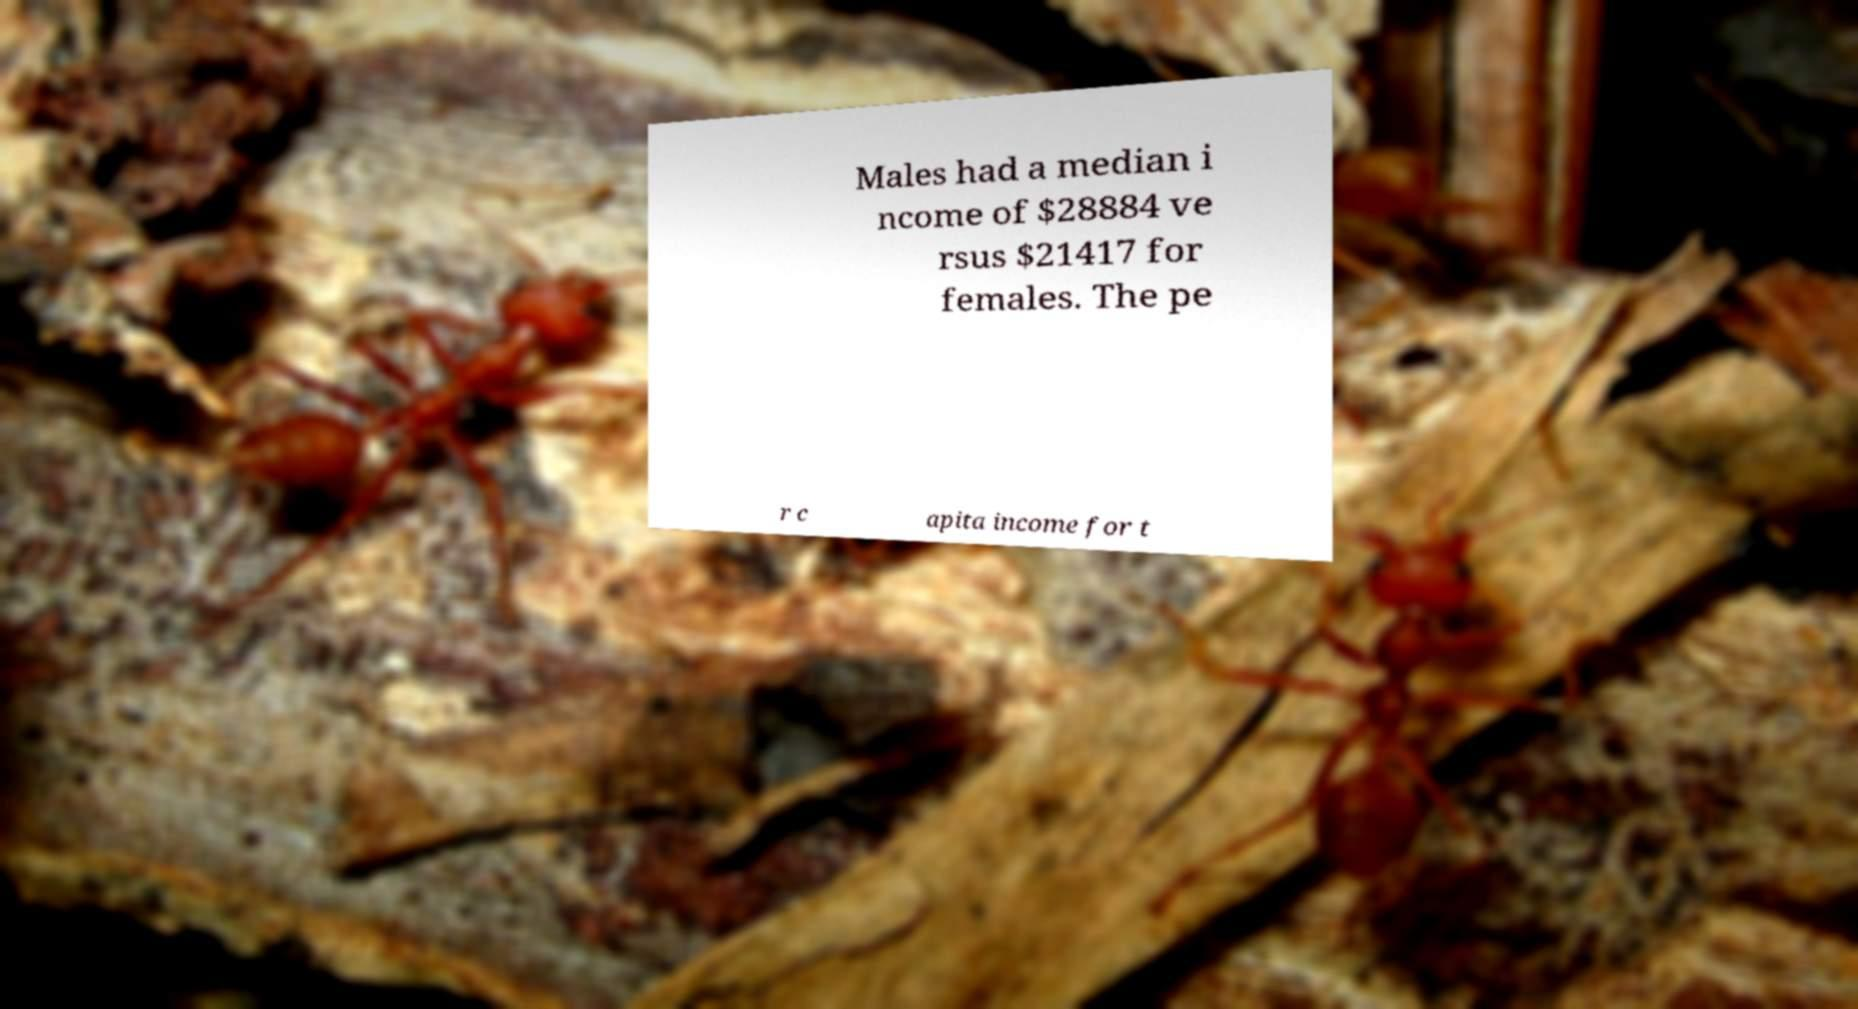Please identify and transcribe the text found in this image. Males had a median i ncome of $28884 ve rsus $21417 for females. The pe r c apita income for t 